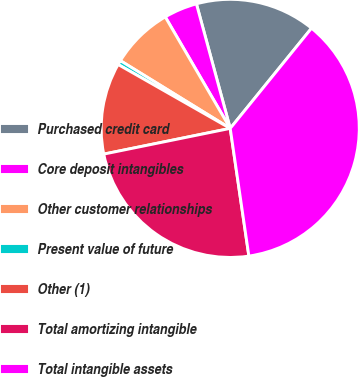<chart> <loc_0><loc_0><loc_500><loc_500><pie_chart><fcel>Purchased credit card<fcel>Core deposit intangibles<fcel>Other customer relationships<fcel>Present value of future<fcel>Other (1)<fcel>Total amortizing intangible<fcel>Total intangible assets<nl><fcel>15.07%<fcel>4.18%<fcel>7.81%<fcel>0.55%<fcel>11.44%<fcel>24.12%<fcel>36.85%<nl></chart> 